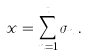<formula> <loc_0><loc_0><loc_500><loc_500>x = \sum _ { n = 1 } ^ { t } \sigma _ { n } \, .</formula> 